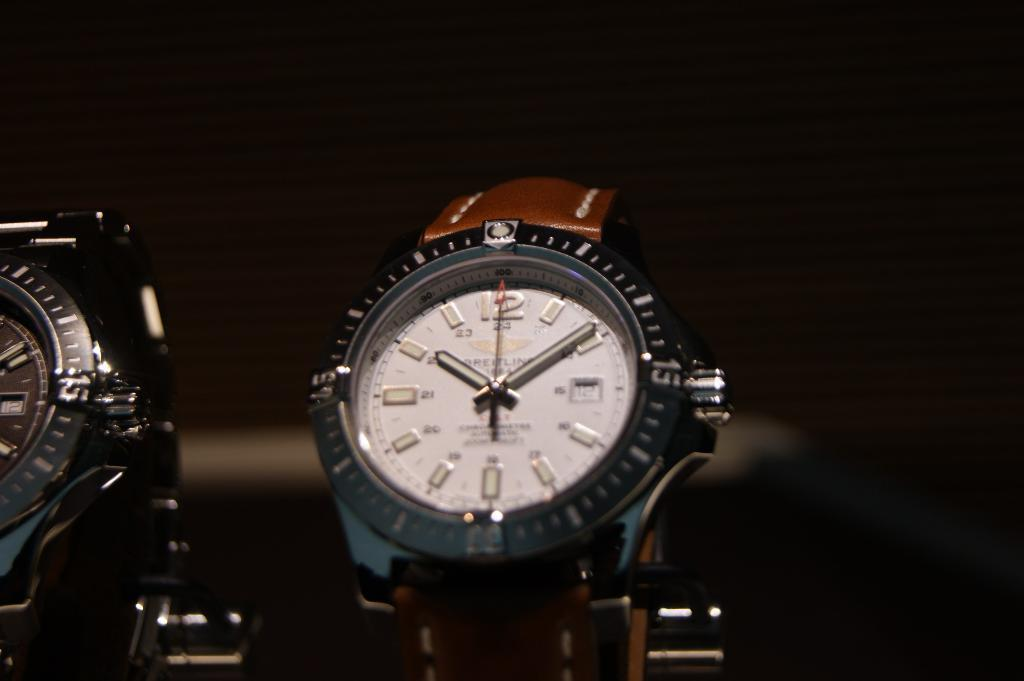<image>
Write a terse but informative summary of the picture. A Breitling watch has an eagle icon right above the name. 